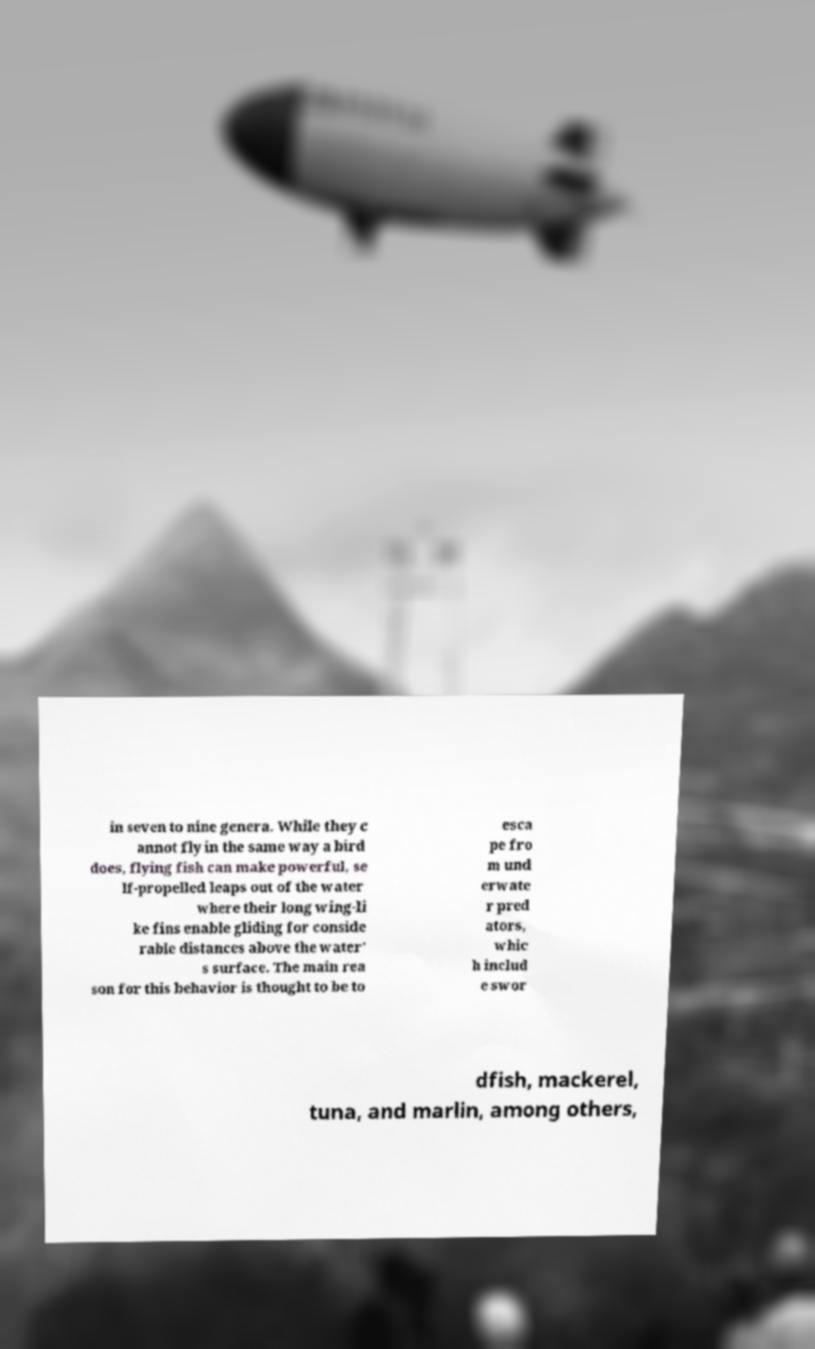Can you accurately transcribe the text from the provided image for me? in seven to nine genera. While they c annot fly in the same way a bird does, flying fish can make powerful, se lf-propelled leaps out of the water where their long wing-li ke fins enable gliding for conside rable distances above the water' s surface. The main rea son for this behavior is thought to be to esca pe fro m und erwate r pred ators, whic h includ e swor dfish, mackerel, tuna, and marlin, among others, 